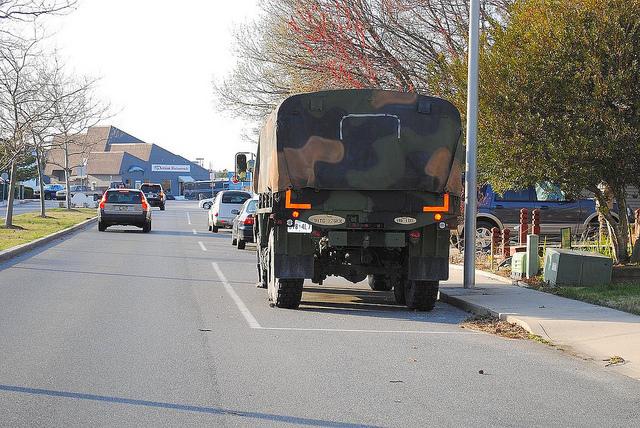Is the car on the left hitting it's brakes?
Write a very short answer. Yes. What color is the truck in the back?
Give a very brief answer. Camo. What color are the tail lights on the back of this truck?
Be succinct. Red. 